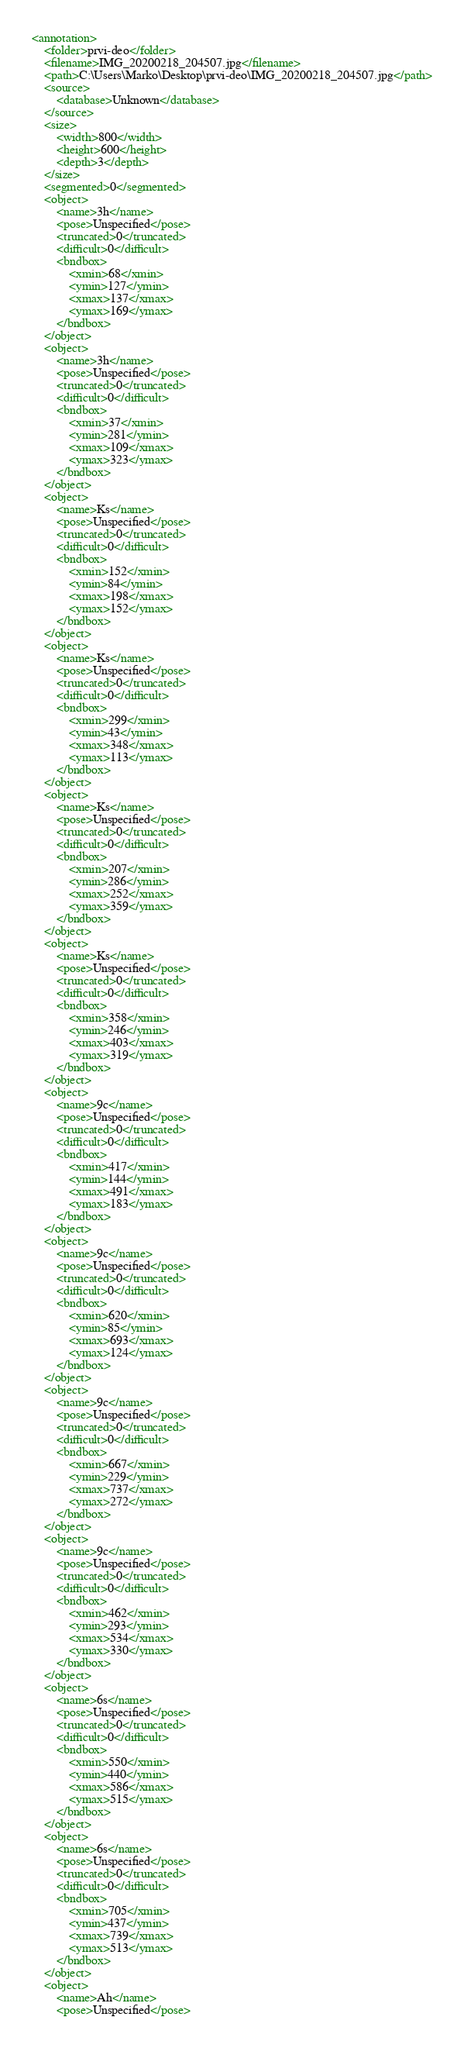Convert code to text. <code><loc_0><loc_0><loc_500><loc_500><_XML_><annotation>
	<folder>prvi-deo</folder>
	<filename>IMG_20200218_204507.jpg</filename>
	<path>C:\Users\Marko\Desktop\prvi-deo\IMG_20200218_204507.jpg</path>
	<source>
		<database>Unknown</database>
	</source>
	<size>
		<width>800</width>
		<height>600</height>
		<depth>3</depth>
	</size>
	<segmented>0</segmented>
	<object>
		<name>3h</name>
		<pose>Unspecified</pose>
		<truncated>0</truncated>
		<difficult>0</difficult>
		<bndbox>
			<xmin>68</xmin>
			<ymin>127</ymin>
			<xmax>137</xmax>
			<ymax>169</ymax>
		</bndbox>
	</object>
	<object>
		<name>3h</name>
		<pose>Unspecified</pose>
		<truncated>0</truncated>
		<difficult>0</difficult>
		<bndbox>
			<xmin>37</xmin>
			<ymin>281</ymin>
			<xmax>109</xmax>
			<ymax>323</ymax>
		</bndbox>
	</object>
	<object>
		<name>Ks</name>
		<pose>Unspecified</pose>
		<truncated>0</truncated>
		<difficult>0</difficult>
		<bndbox>
			<xmin>152</xmin>
			<ymin>84</ymin>
			<xmax>198</xmax>
			<ymax>152</ymax>
		</bndbox>
	</object>
	<object>
		<name>Ks</name>
		<pose>Unspecified</pose>
		<truncated>0</truncated>
		<difficult>0</difficult>
		<bndbox>
			<xmin>299</xmin>
			<ymin>43</ymin>
			<xmax>348</xmax>
			<ymax>113</ymax>
		</bndbox>
	</object>
	<object>
		<name>Ks</name>
		<pose>Unspecified</pose>
		<truncated>0</truncated>
		<difficult>0</difficult>
		<bndbox>
			<xmin>207</xmin>
			<ymin>286</ymin>
			<xmax>252</xmax>
			<ymax>359</ymax>
		</bndbox>
	</object>
	<object>
		<name>Ks</name>
		<pose>Unspecified</pose>
		<truncated>0</truncated>
		<difficult>0</difficult>
		<bndbox>
			<xmin>358</xmin>
			<ymin>246</ymin>
			<xmax>403</xmax>
			<ymax>319</ymax>
		</bndbox>
	</object>
	<object>
		<name>9c</name>
		<pose>Unspecified</pose>
		<truncated>0</truncated>
		<difficult>0</difficult>
		<bndbox>
			<xmin>417</xmin>
			<ymin>144</ymin>
			<xmax>491</xmax>
			<ymax>183</ymax>
		</bndbox>
	</object>
	<object>
		<name>9c</name>
		<pose>Unspecified</pose>
		<truncated>0</truncated>
		<difficult>0</difficult>
		<bndbox>
			<xmin>620</xmin>
			<ymin>85</ymin>
			<xmax>693</xmax>
			<ymax>124</ymax>
		</bndbox>
	</object>
	<object>
		<name>9c</name>
		<pose>Unspecified</pose>
		<truncated>0</truncated>
		<difficult>0</difficult>
		<bndbox>
			<xmin>667</xmin>
			<ymin>229</ymin>
			<xmax>737</xmax>
			<ymax>272</ymax>
		</bndbox>
	</object>
	<object>
		<name>9c</name>
		<pose>Unspecified</pose>
		<truncated>0</truncated>
		<difficult>0</difficult>
		<bndbox>
			<xmin>462</xmin>
			<ymin>293</ymin>
			<xmax>534</xmax>
			<ymax>330</ymax>
		</bndbox>
	</object>
	<object>
		<name>6s</name>
		<pose>Unspecified</pose>
		<truncated>0</truncated>
		<difficult>0</difficult>
		<bndbox>
			<xmin>550</xmin>
			<ymin>440</ymin>
			<xmax>586</xmax>
			<ymax>515</ymax>
		</bndbox>
	</object>
	<object>
		<name>6s</name>
		<pose>Unspecified</pose>
		<truncated>0</truncated>
		<difficult>0</difficult>
		<bndbox>
			<xmin>705</xmin>
			<ymin>437</ymin>
			<xmax>739</xmax>
			<ymax>513</ymax>
		</bndbox>
	</object>
	<object>
		<name>Ah</name>
		<pose>Unspecified</pose></code> 